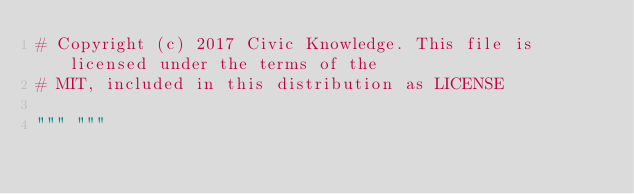Convert code to text. <code><loc_0><loc_0><loc_500><loc_500><_Python_># Copyright (c) 2017 Civic Knowledge. This file is licensed under the terms of the
# MIT, included in this distribution as LICENSE

""" """</code> 